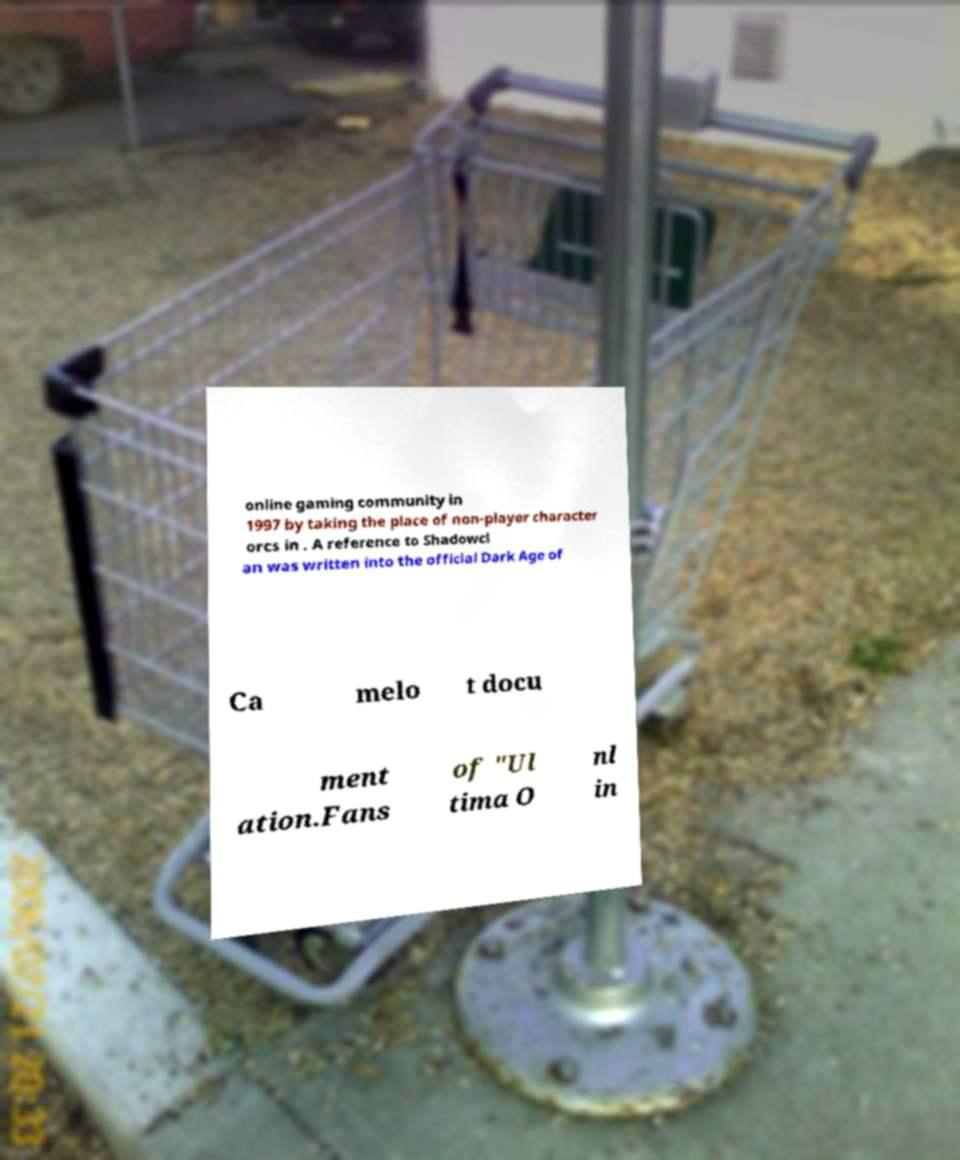Can you read and provide the text displayed in the image?This photo seems to have some interesting text. Can you extract and type it out for me? online gaming community in 1997 by taking the place of non-player character orcs in . A reference to Shadowcl an was written into the official Dark Age of Ca melo t docu ment ation.Fans of "Ul tima O nl in 